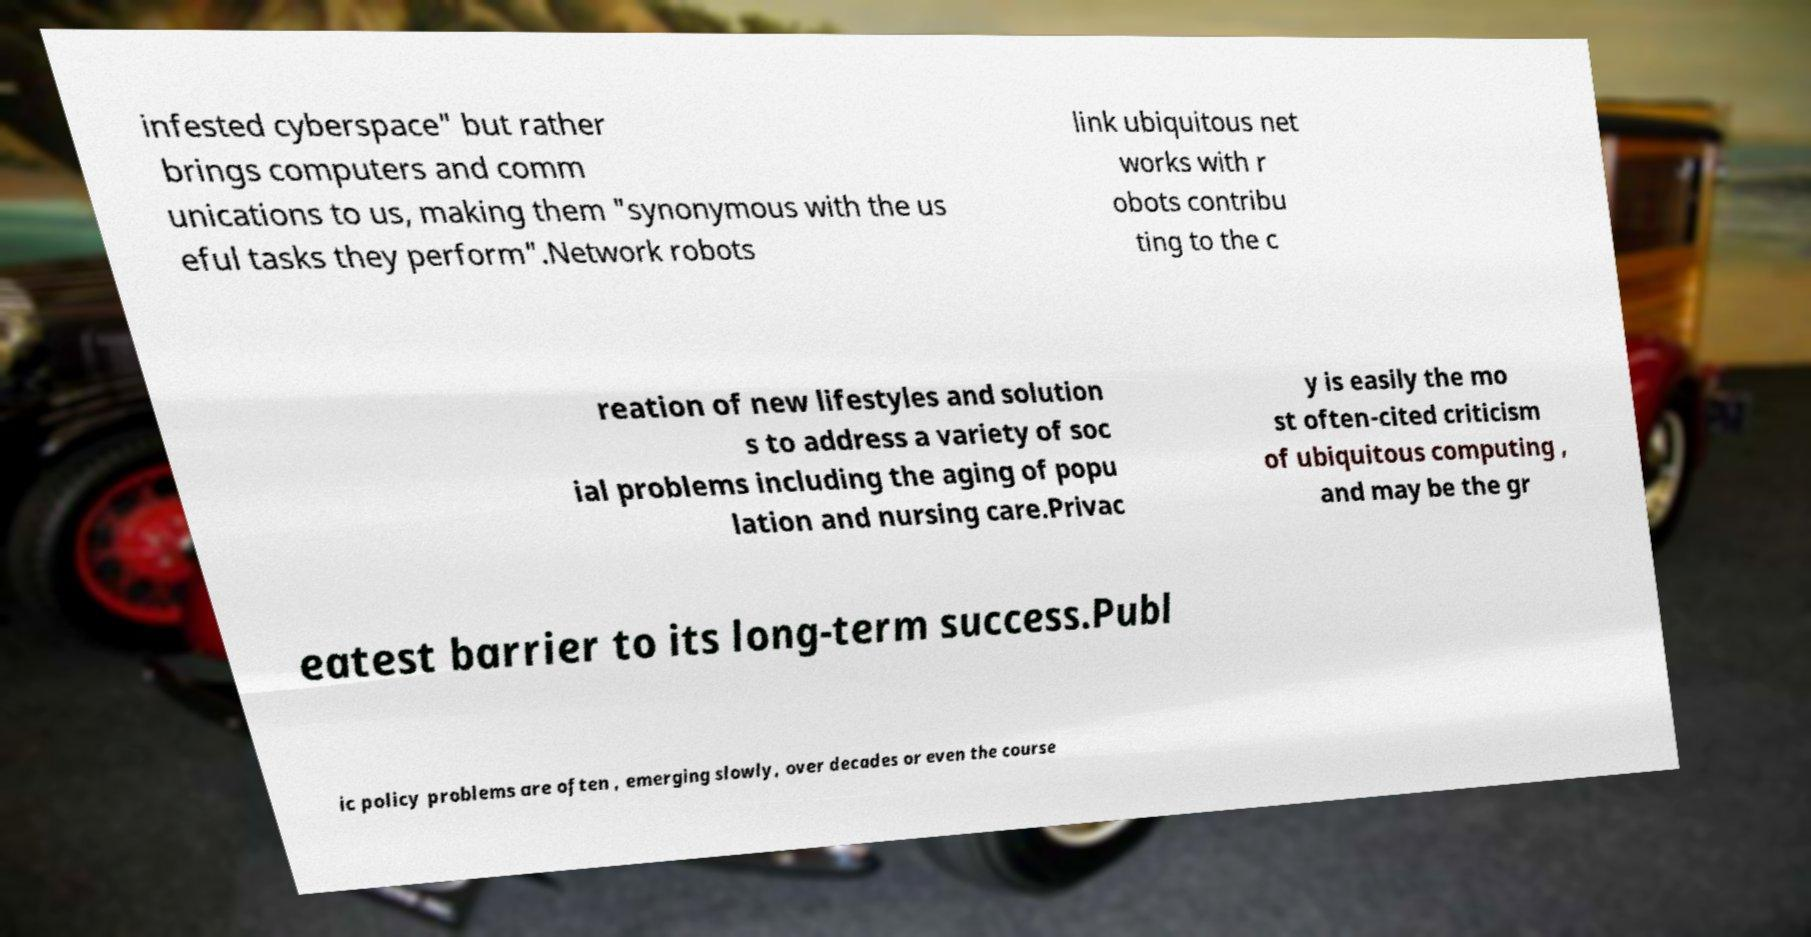Can you read and provide the text displayed in the image?This photo seems to have some interesting text. Can you extract and type it out for me? infested cyberspace" but rather brings computers and comm unications to us, making them "synonymous with the us eful tasks they perform".Network robots link ubiquitous net works with r obots contribu ting to the c reation of new lifestyles and solution s to address a variety of soc ial problems including the aging of popu lation and nursing care.Privac y is easily the mo st often-cited criticism of ubiquitous computing , and may be the gr eatest barrier to its long-term success.Publ ic policy problems are often , emerging slowly, over decades or even the course 